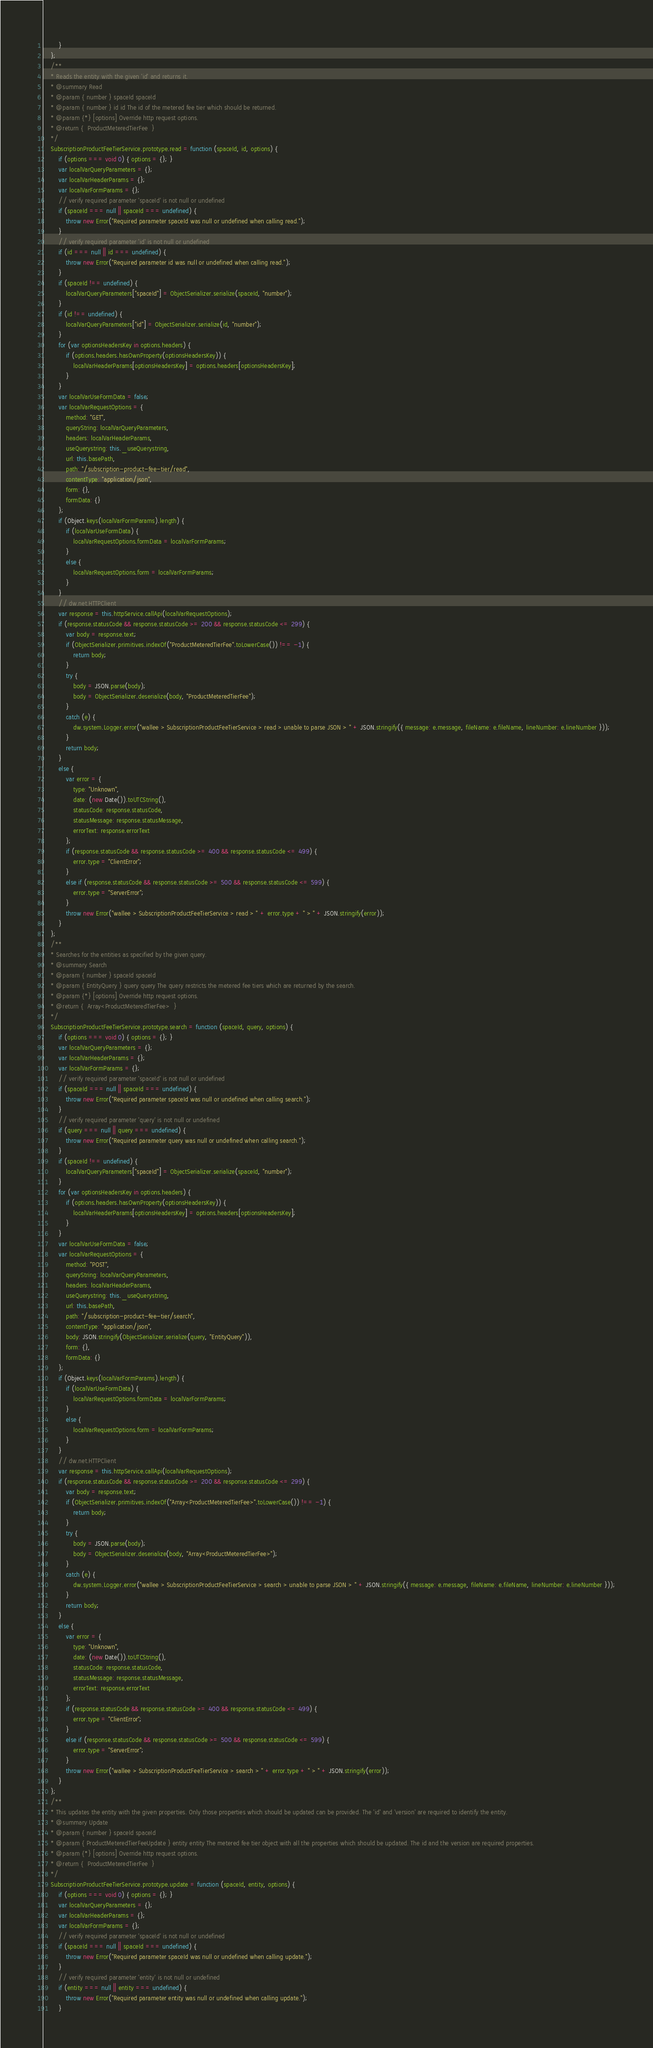<code> <loc_0><loc_0><loc_500><loc_500><_JavaScript_>        }
    };
    /**
    * Reads the entity with the given 'id' and returns it.
    * @summary Read
    * @param { number } spaceId spaceId
    * @param { number } id id The id of the metered fee tier which should be returned.
    * @param {*} [options] Override http request options.
    * @return {  ProductMeteredTierFee  }
    */
    SubscriptionProductFeeTierService.prototype.read = function (spaceId, id, options) {
        if (options === void 0) { options = {}; }
        var localVarQueryParameters = {};
        var localVarHeaderParams = {};
        var localVarFormParams = {};
        // verify required parameter 'spaceId' is not null or undefined
        if (spaceId === null || spaceId === undefined) {
            throw new Error("Required parameter spaceId was null or undefined when calling read.");
        }
        // verify required parameter 'id' is not null or undefined
        if (id === null || id === undefined) {
            throw new Error("Required parameter id was null or undefined when calling read.");
        }
        if (spaceId !== undefined) {
            localVarQueryParameters["spaceId"] = ObjectSerializer.serialize(spaceId, "number");
        }
        if (id !== undefined) {
            localVarQueryParameters["id"] = ObjectSerializer.serialize(id, "number");
        }
        for (var optionsHeadersKey in options.headers) {
            if (options.headers.hasOwnProperty(optionsHeadersKey)) {
                localVarHeaderParams[optionsHeadersKey] = options.headers[optionsHeadersKey];
            }
        }
        var localVarUseFormData = false;
        var localVarRequestOptions = {
            method: "GET",
            queryString: localVarQueryParameters,
            headers: localVarHeaderParams,
            useQuerystring: this._useQuerystring,
            url: this.basePath,
            path: "/subscription-product-fee-tier/read",
            contentType: "application/json",
            form: {},
            formData: {}
        };
        if (Object.keys(localVarFormParams).length) {
            if (localVarUseFormData) {
                localVarRequestOptions.formData = localVarFormParams;
            }
            else {
                localVarRequestOptions.form = localVarFormParams;
            }
        }
        // dw.net.HTTPClient
        var response = this.httpService.callApi(localVarRequestOptions);
        if (response.statusCode && response.statusCode >= 200 && response.statusCode <= 299) {
            var body = response.text;
            if (ObjectSerializer.primitives.indexOf("ProductMeteredTierFee".toLowerCase()) !== -1) {
                return body;
            }
            try {
                body = JSON.parse(body);
                body = ObjectSerializer.deserialize(body, "ProductMeteredTierFee");
            }
            catch (e) {
                dw.system.Logger.error("wallee > SubscriptionProductFeeTierService > read > unable to parse JSON > " + JSON.stringify({ message: e.message, fileName: e.fileName, lineNumber: e.lineNumber }));
            }
            return body;
        }
        else {
            var error = {
                type: "Unknown",
                date: (new Date()).toUTCString(),
                statusCode: response.statusCode,
                statusMessage: response.statusMessage,
                errorText: response.errorText
            };
            if (response.statusCode && response.statusCode >= 400 && response.statusCode <= 499) {
                error.type = "ClientError";
            }
            else if (response.statusCode && response.statusCode >= 500 && response.statusCode <= 599) {
                error.type = "ServerError";
            }
            throw new Error("wallee > SubscriptionProductFeeTierService > read > " + error.type + " > " + JSON.stringify(error));
        }
    };
    /**
    * Searches for the entities as specified by the given query.
    * @summary Search
    * @param { number } spaceId spaceId
    * @param { EntityQuery } query query The query restricts the metered fee tiers which are returned by the search.
    * @param {*} [options] Override http request options.
    * @return {  Array<ProductMeteredTierFee>  }
    */
    SubscriptionProductFeeTierService.prototype.search = function (spaceId, query, options) {
        if (options === void 0) { options = {}; }
        var localVarQueryParameters = {};
        var localVarHeaderParams = {};
        var localVarFormParams = {};
        // verify required parameter 'spaceId' is not null or undefined
        if (spaceId === null || spaceId === undefined) {
            throw new Error("Required parameter spaceId was null or undefined when calling search.");
        }
        // verify required parameter 'query' is not null or undefined
        if (query === null || query === undefined) {
            throw new Error("Required parameter query was null or undefined when calling search.");
        }
        if (spaceId !== undefined) {
            localVarQueryParameters["spaceId"] = ObjectSerializer.serialize(spaceId, "number");
        }
        for (var optionsHeadersKey in options.headers) {
            if (options.headers.hasOwnProperty(optionsHeadersKey)) {
                localVarHeaderParams[optionsHeadersKey] = options.headers[optionsHeadersKey];
            }
        }
        var localVarUseFormData = false;
        var localVarRequestOptions = {
            method: "POST",
            queryString: localVarQueryParameters,
            headers: localVarHeaderParams,
            useQuerystring: this._useQuerystring,
            url: this.basePath,
            path: "/subscription-product-fee-tier/search",
            contentType: "application/json",
            body: JSON.stringify(ObjectSerializer.serialize(query, "EntityQuery")),
            form: {},
            formData: {}
        };
        if (Object.keys(localVarFormParams).length) {
            if (localVarUseFormData) {
                localVarRequestOptions.formData = localVarFormParams;
            }
            else {
                localVarRequestOptions.form = localVarFormParams;
            }
        }
        // dw.net.HTTPClient
        var response = this.httpService.callApi(localVarRequestOptions);
        if (response.statusCode && response.statusCode >= 200 && response.statusCode <= 299) {
            var body = response.text;
            if (ObjectSerializer.primitives.indexOf("Array<ProductMeteredTierFee>".toLowerCase()) !== -1) {
                return body;
            }
            try {
                body = JSON.parse(body);
                body = ObjectSerializer.deserialize(body, "Array<ProductMeteredTierFee>");
            }
            catch (e) {
                dw.system.Logger.error("wallee > SubscriptionProductFeeTierService > search > unable to parse JSON > " + JSON.stringify({ message: e.message, fileName: e.fileName, lineNumber: e.lineNumber }));
            }
            return body;
        }
        else {
            var error = {
                type: "Unknown",
                date: (new Date()).toUTCString(),
                statusCode: response.statusCode,
                statusMessage: response.statusMessage,
                errorText: response.errorText
            };
            if (response.statusCode && response.statusCode >= 400 && response.statusCode <= 499) {
                error.type = "ClientError";
            }
            else if (response.statusCode && response.statusCode >= 500 && response.statusCode <= 599) {
                error.type = "ServerError";
            }
            throw new Error("wallee > SubscriptionProductFeeTierService > search > " + error.type + " > " + JSON.stringify(error));
        }
    };
    /**
    * This updates the entity with the given properties. Only those properties which should be updated can be provided. The 'id' and 'version' are required to identify the entity.
    * @summary Update
    * @param { number } spaceId spaceId
    * @param { ProductMeteredTierFeeUpdate } entity entity The metered fee tier object with all the properties which should be updated. The id and the version are required properties.
    * @param {*} [options] Override http request options.
    * @return {  ProductMeteredTierFee  }
    */
    SubscriptionProductFeeTierService.prototype.update = function (spaceId, entity, options) {
        if (options === void 0) { options = {}; }
        var localVarQueryParameters = {};
        var localVarHeaderParams = {};
        var localVarFormParams = {};
        // verify required parameter 'spaceId' is not null or undefined
        if (spaceId === null || spaceId === undefined) {
            throw new Error("Required parameter spaceId was null or undefined when calling update.");
        }
        // verify required parameter 'entity' is not null or undefined
        if (entity === null || entity === undefined) {
            throw new Error("Required parameter entity was null or undefined when calling update.");
        }</code> 